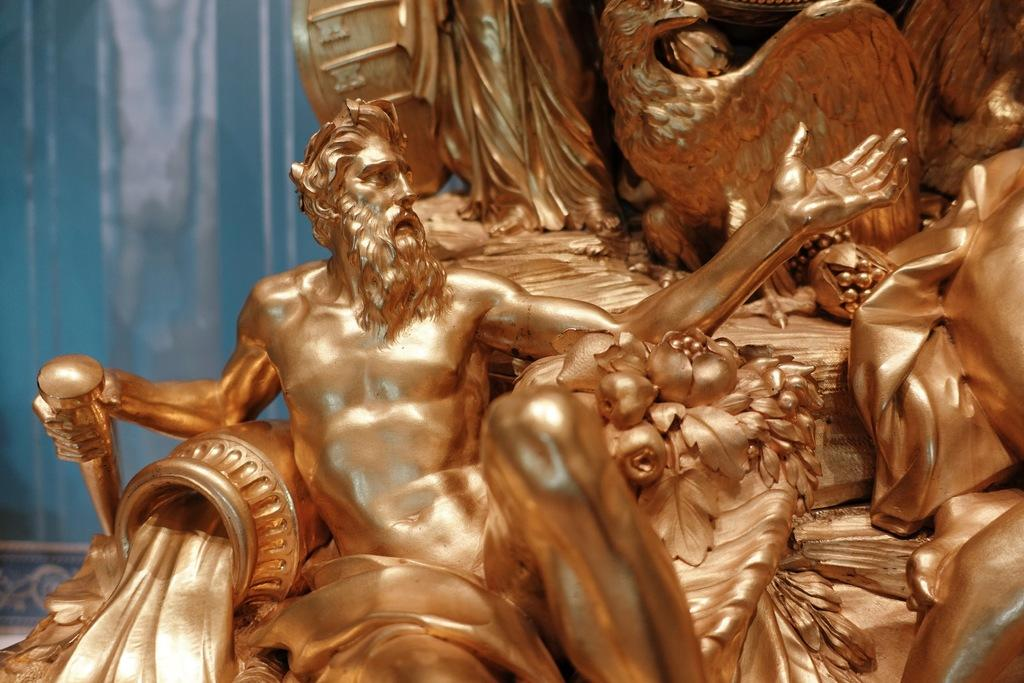What type of art is present in the image? There are sculptures in the image. What color is the background of the image? The background of the image is blue in color. How many toes can be seen on the sculptures in the image? There is no information about toes on the sculptures in the image, as the facts provided do not mention any specific details about the sculptures themselves. 